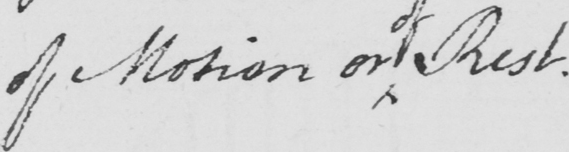Can you read and transcribe this handwriting? of Motion or Rest . 